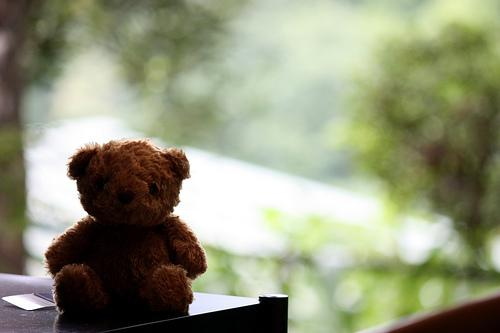Identify one object near the teddy bear and describe its position in relation to the bear. There is a card next to the teddy bear, which is placed on the table beside the bear. Imagine you were advertising this teddy bear for sale. Write a brief promotional text that describes its appearance and qualities. Introducing our adorable brown teddy bear, featuring big, round eyes, a cute little nose, and soft, furry ears. This huggable, lovable companion will be the perfect addition to any child's bedroom or playtime. Bring it home today! What is the color and appearance of the table on which the teddy bear is placed? The table the teddy bear is sitting on is black and appears to be made of dark wood. Based on the image, what do you think might be the purpose of the scene or setting? The scene may be set up for a product advertisement, showcasing the teddy bear and other objects in a pleasing and natural outdoor environment. What features are present on the teddy bear's face, and where are they positioned? The teddy bear has a nose, an eye, and an ear on each side. The nose is placed around the center, the eyes are above the nose, and the ears are on either side of the head. Are there any objects in the background of the image? If so, what are they? Yes, there are objects in the background, including a tree in the distance, a white tent, a bench made of wood, and green leaves on a tree. Looking at the image, would you classify the teddy bear as "cute"? Explain your reasoning. Yes, the teddy bear appears to be cute, as it has a round face, big eyes, and a small nose, which are all features that people generally find cute in animals and toys. What is the main object sitting on the table? A stuffed teddy bear is sitting on the table. Can you tell if the environment is indoor or outdoor and why? The environment is likely outdoor, as there is a tree in the distance, and the background is blurred. Find three different ways to refer to the main object in the scene (the teddy bear). 3. Huggable toy bear 